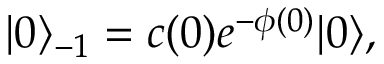Convert formula to latex. <formula><loc_0><loc_0><loc_500><loc_500>| 0 \rangle _ { - 1 } = c ( 0 ) e ^ { - \phi ( 0 ) } | 0 \rangle ,</formula> 